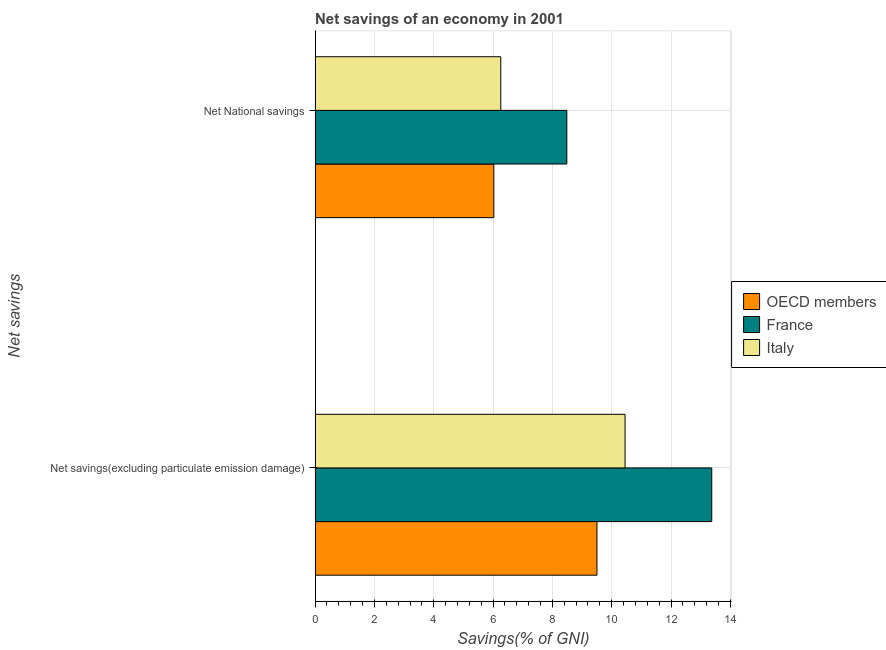Are the number of bars on each tick of the Y-axis equal?
Your response must be concise. Yes. What is the label of the 1st group of bars from the top?
Offer a very short reply. Net National savings. What is the net savings(excluding particulate emission damage) in OECD members?
Give a very brief answer. 9.5. Across all countries, what is the maximum net national savings?
Your answer should be very brief. 8.49. Across all countries, what is the minimum net national savings?
Your response must be concise. 6.03. In which country was the net national savings minimum?
Ensure brevity in your answer.  OECD members. What is the total net savings(excluding particulate emission damage) in the graph?
Provide a succinct answer. 33.33. What is the difference between the net national savings in France and that in Italy?
Provide a succinct answer. 2.23. What is the difference between the net savings(excluding particulate emission damage) in OECD members and the net national savings in France?
Ensure brevity in your answer.  1.02. What is the average net savings(excluding particulate emission damage) per country?
Keep it short and to the point. 11.11. What is the difference between the net national savings and net savings(excluding particulate emission damage) in OECD members?
Keep it short and to the point. -3.48. In how many countries, is the net savings(excluding particulate emission damage) greater than 7.6 %?
Ensure brevity in your answer.  3. What is the ratio of the net savings(excluding particulate emission damage) in France to that in Italy?
Make the answer very short. 1.28. Is the net national savings in OECD members less than that in Italy?
Your answer should be compact. Yes. In how many countries, is the net national savings greater than the average net national savings taken over all countries?
Give a very brief answer. 1. What does the 3rd bar from the top in Net National savings represents?
Your answer should be compact. OECD members. What does the 2nd bar from the bottom in Net National savings represents?
Ensure brevity in your answer.  France. How many bars are there?
Give a very brief answer. 6. Are the values on the major ticks of X-axis written in scientific E-notation?
Provide a succinct answer. No. Does the graph contain any zero values?
Make the answer very short. No. Where does the legend appear in the graph?
Your answer should be very brief. Center right. How many legend labels are there?
Make the answer very short. 3. How are the legend labels stacked?
Provide a short and direct response. Vertical. What is the title of the graph?
Your answer should be very brief. Net savings of an economy in 2001. Does "Comoros" appear as one of the legend labels in the graph?
Offer a terse response. No. What is the label or title of the X-axis?
Offer a very short reply. Savings(% of GNI). What is the label or title of the Y-axis?
Offer a very short reply. Net savings. What is the Savings(% of GNI) in OECD members in Net savings(excluding particulate emission damage)?
Make the answer very short. 9.5. What is the Savings(% of GNI) in France in Net savings(excluding particulate emission damage)?
Your answer should be very brief. 13.37. What is the Savings(% of GNI) of Italy in Net savings(excluding particulate emission damage)?
Ensure brevity in your answer.  10.45. What is the Savings(% of GNI) of OECD members in Net National savings?
Make the answer very short. 6.03. What is the Savings(% of GNI) in France in Net National savings?
Keep it short and to the point. 8.49. What is the Savings(% of GNI) in Italy in Net National savings?
Provide a succinct answer. 6.26. Across all Net savings, what is the maximum Savings(% of GNI) in OECD members?
Your response must be concise. 9.5. Across all Net savings, what is the maximum Savings(% of GNI) of France?
Your answer should be very brief. 13.37. Across all Net savings, what is the maximum Savings(% of GNI) in Italy?
Your response must be concise. 10.45. Across all Net savings, what is the minimum Savings(% of GNI) in OECD members?
Provide a succinct answer. 6.03. Across all Net savings, what is the minimum Savings(% of GNI) in France?
Give a very brief answer. 8.49. Across all Net savings, what is the minimum Savings(% of GNI) in Italy?
Your answer should be very brief. 6.26. What is the total Savings(% of GNI) in OECD members in the graph?
Your answer should be very brief. 15.53. What is the total Savings(% of GNI) of France in the graph?
Give a very brief answer. 21.86. What is the total Savings(% of GNI) in Italy in the graph?
Offer a very short reply. 16.71. What is the difference between the Savings(% of GNI) in OECD members in Net savings(excluding particulate emission damage) and that in Net National savings?
Keep it short and to the point. 3.48. What is the difference between the Savings(% of GNI) in France in Net savings(excluding particulate emission damage) and that in Net National savings?
Your answer should be compact. 4.89. What is the difference between the Savings(% of GNI) of Italy in Net savings(excluding particulate emission damage) and that in Net National savings?
Provide a short and direct response. 4.19. What is the difference between the Savings(% of GNI) of OECD members in Net savings(excluding particulate emission damage) and the Savings(% of GNI) of France in Net National savings?
Offer a terse response. 1.02. What is the difference between the Savings(% of GNI) in OECD members in Net savings(excluding particulate emission damage) and the Savings(% of GNI) in Italy in Net National savings?
Provide a short and direct response. 3.24. What is the difference between the Savings(% of GNI) in France in Net savings(excluding particulate emission damage) and the Savings(% of GNI) in Italy in Net National savings?
Offer a very short reply. 7.11. What is the average Savings(% of GNI) in OECD members per Net savings?
Your response must be concise. 7.76. What is the average Savings(% of GNI) in France per Net savings?
Your response must be concise. 10.93. What is the average Savings(% of GNI) in Italy per Net savings?
Offer a very short reply. 8.35. What is the difference between the Savings(% of GNI) in OECD members and Savings(% of GNI) in France in Net savings(excluding particulate emission damage)?
Your answer should be compact. -3.87. What is the difference between the Savings(% of GNI) in OECD members and Savings(% of GNI) in Italy in Net savings(excluding particulate emission damage)?
Provide a succinct answer. -0.95. What is the difference between the Savings(% of GNI) of France and Savings(% of GNI) of Italy in Net savings(excluding particulate emission damage)?
Provide a short and direct response. 2.92. What is the difference between the Savings(% of GNI) in OECD members and Savings(% of GNI) in France in Net National savings?
Give a very brief answer. -2.46. What is the difference between the Savings(% of GNI) of OECD members and Savings(% of GNI) of Italy in Net National savings?
Keep it short and to the point. -0.23. What is the difference between the Savings(% of GNI) in France and Savings(% of GNI) in Italy in Net National savings?
Ensure brevity in your answer.  2.23. What is the ratio of the Savings(% of GNI) of OECD members in Net savings(excluding particulate emission damage) to that in Net National savings?
Provide a succinct answer. 1.58. What is the ratio of the Savings(% of GNI) of France in Net savings(excluding particulate emission damage) to that in Net National savings?
Ensure brevity in your answer.  1.58. What is the ratio of the Savings(% of GNI) in Italy in Net savings(excluding particulate emission damage) to that in Net National savings?
Offer a terse response. 1.67. What is the difference between the highest and the second highest Savings(% of GNI) in OECD members?
Keep it short and to the point. 3.48. What is the difference between the highest and the second highest Savings(% of GNI) of France?
Give a very brief answer. 4.89. What is the difference between the highest and the second highest Savings(% of GNI) in Italy?
Offer a very short reply. 4.19. What is the difference between the highest and the lowest Savings(% of GNI) of OECD members?
Provide a succinct answer. 3.48. What is the difference between the highest and the lowest Savings(% of GNI) of France?
Make the answer very short. 4.89. What is the difference between the highest and the lowest Savings(% of GNI) of Italy?
Offer a very short reply. 4.19. 